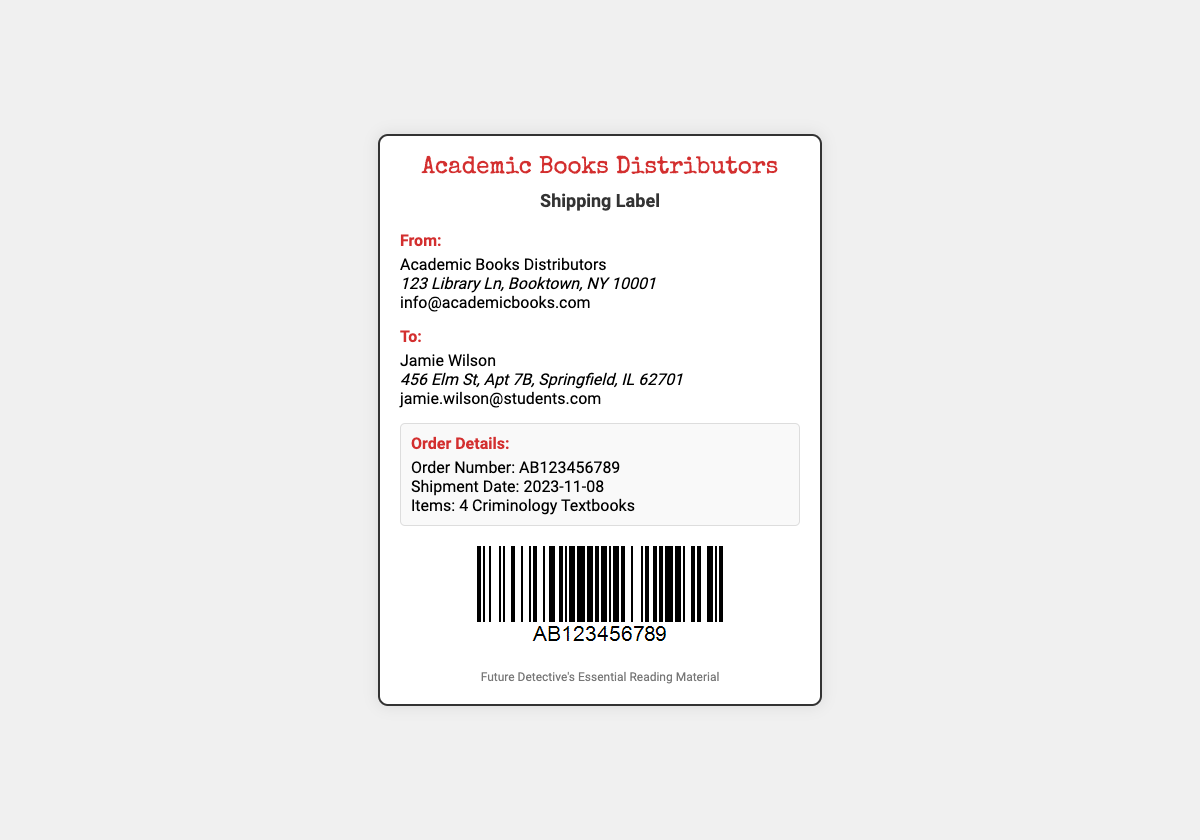What is the sender's name? The sender's name is listed at the top section under "From:".
Answer: Academic Books Distributors What is the recipient's email address? The recipient's email is displayed in the "To:" section.
Answer: jamie.wilson@students.com What is the order number? The order number is found in the "Order Details:" section.
Answer: AB123456789 How many criminology textbooks were ordered? The number of ordered textbooks is specified in the order details.
Answer: 4 Criminology Textbooks What is the shipment date? The date of shipment is provided in the "Order Details:" section.
Answer: 2023-11-08 Where is the sender located? The address of the sender is mentioned under the "From:" section.
Answer: 123 Library Ln, Booktown, NY 10001 What is the purpose of this document? The primary purpose of the document is indicated in the title at the top.
Answer: Shipping Label What type of document is this? The document type is specified in the header section.
Answer: Shipping Label 